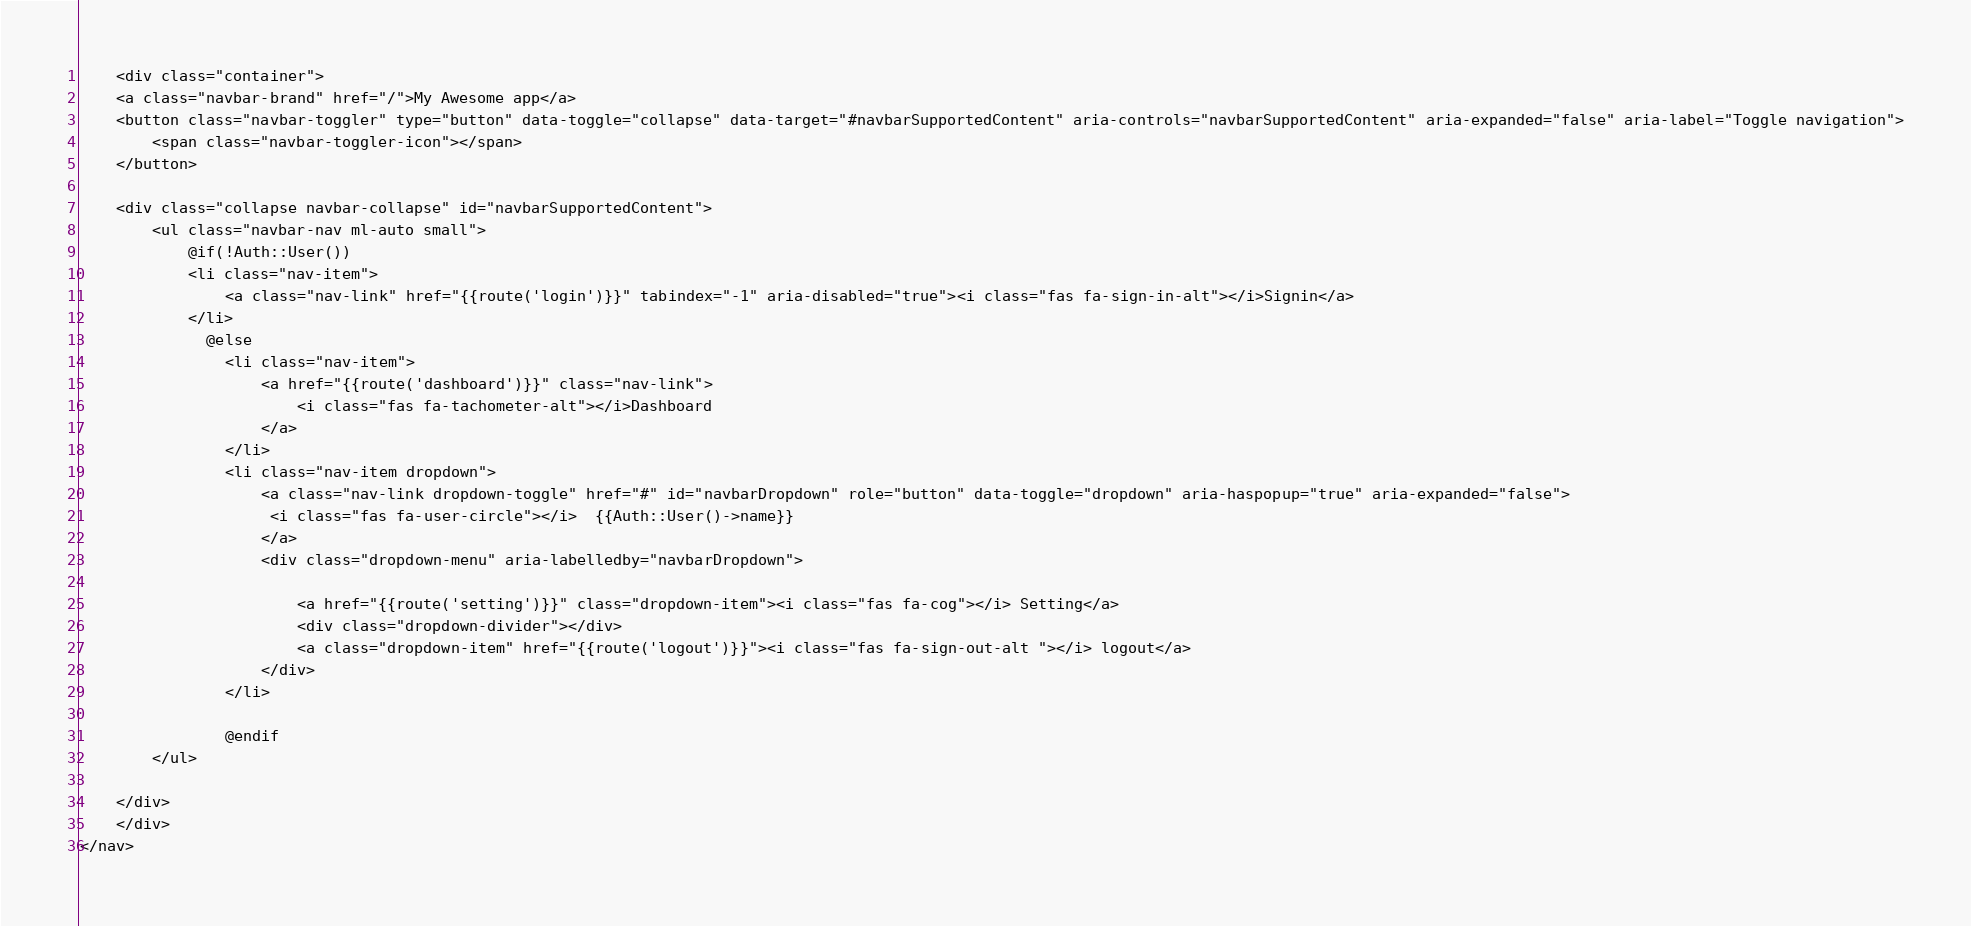<code> <loc_0><loc_0><loc_500><loc_500><_PHP_>    <div class="container">
    <a class="navbar-brand" href="/">My Awesome app</a>
    <button class="navbar-toggler" type="button" data-toggle="collapse" data-target="#navbarSupportedContent" aria-controls="navbarSupportedContent" aria-expanded="false" aria-label="Toggle navigation">
        <span class="navbar-toggler-icon"></span>
    </button>

    <div class="collapse navbar-collapse" id="navbarSupportedContent">
        <ul class="navbar-nav ml-auto small">
            @if(!Auth::User())
            <li class="nav-item">
                <a class="nav-link" href="{{route('login')}}" tabindex="-1" aria-disabled="true"><i class="fas fa-sign-in-alt"></i>Signin</a>
            </li>
              @else
                <li class="nav-item">
                    <a href="{{route('dashboard')}}" class="nav-link">
                        <i class="fas fa-tachometer-alt"></i>Dashboard
                    </a>
                </li>
                <li class="nav-item dropdown">
                    <a class="nav-link dropdown-toggle" href="#" id="navbarDropdown" role="button" data-toggle="dropdown" aria-haspopup="true" aria-expanded="false">
                     <i class="fas fa-user-circle"></i>  {{Auth::User()->name}}
                    </a>
                    <div class="dropdown-menu" aria-labelledby="navbarDropdown">

                        <a href="{{route('setting')}}" class="dropdown-item"><i class="fas fa-cog"></i> Setting</a>
                        <div class="dropdown-divider"></div>
                        <a class="dropdown-item" href="{{route('logout')}}"><i class="fas fa-sign-out-alt "></i> logout</a>
                    </div>
                </li>

                @endif
        </ul>

    </div>
    </div>
</nav>
</code> 